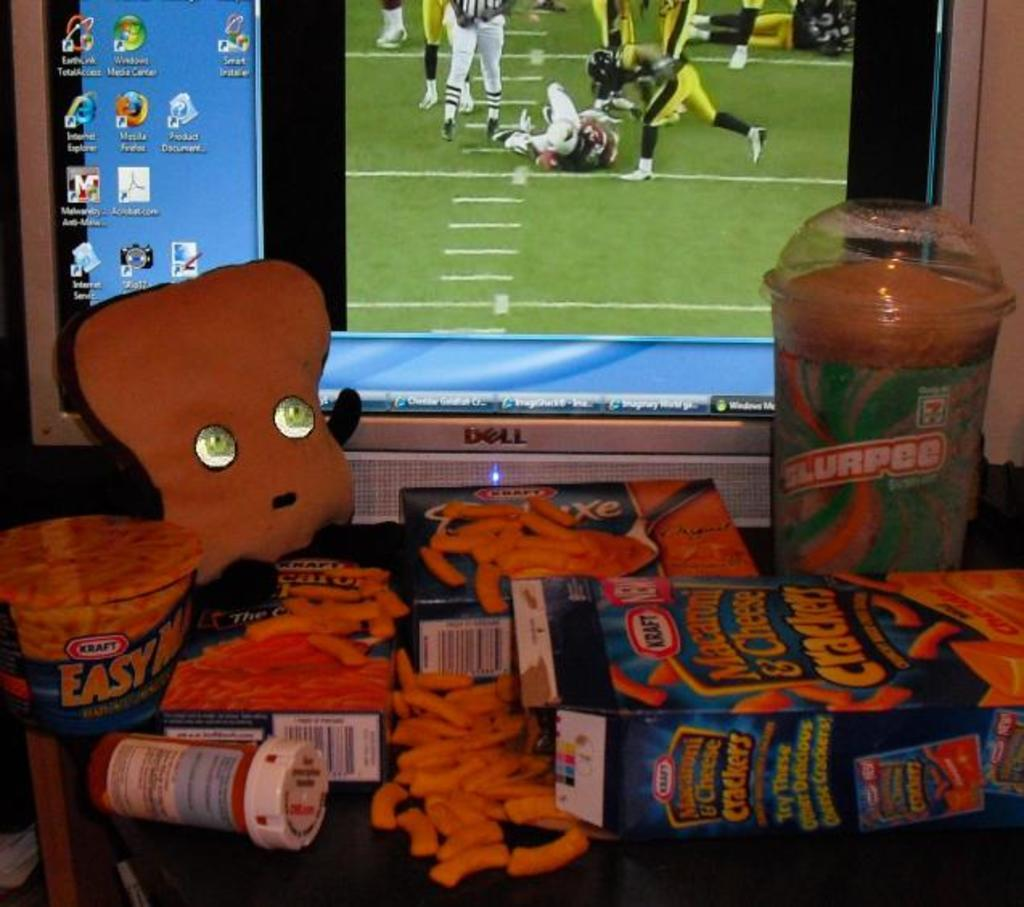<image>
Write a terse but informative summary of the picture. A box of Kraft Macaroni & Cheese Crackers. 